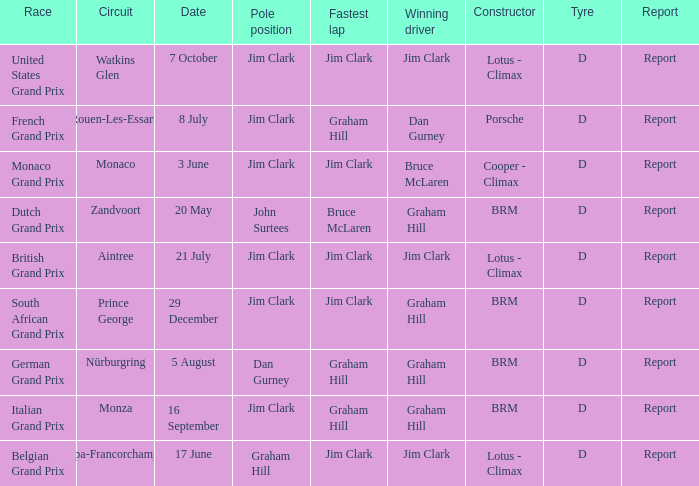Would you mind parsing the complete table? {'header': ['Race', 'Circuit', 'Date', 'Pole position', 'Fastest lap', 'Winning driver', 'Constructor', 'Tyre', 'Report'], 'rows': [['United States Grand Prix', 'Watkins Glen', '7 October', 'Jim Clark', 'Jim Clark', 'Jim Clark', 'Lotus - Climax', 'D', 'Report'], ['French Grand Prix', 'Rouen-Les-Essarts', '8 July', 'Jim Clark', 'Graham Hill', 'Dan Gurney', 'Porsche', 'D', 'Report'], ['Monaco Grand Prix', 'Monaco', '3 June', 'Jim Clark', 'Jim Clark', 'Bruce McLaren', 'Cooper - Climax', 'D', 'Report'], ['Dutch Grand Prix', 'Zandvoort', '20 May', 'John Surtees', 'Bruce McLaren', 'Graham Hill', 'BRM', 'D', 'Report'], ['British Grand Prix', 'Aintree', '21 July', 'Jim Clark', 'Jim Clark', 'Jim Clark', 'Lotus - Climax', 'D', 'Report'], ['South African Grand Prix', 'Prince George', '29 December', 'Jim Clark', 'Jim Clark', 'Graham Hill', 'BRM', 'D', 'Report'], ['German Grand Prix', 'Nürburgring', '5 August', 'Dan Gurney', 'Graham Hill', 'Graham Hill', 'BRM', 'D', 'Report'], ['Italian Grand Prix', 'Monza', '16 September', 'Jim Clark', 'Graham Hill', 'Graham Hill', 'BRM', 'D', 'Report'], ['Belgian Grand Prix', 'Spa-Francorchamps', '17 June', 'Graham Hill', 'Jim Clark', 'Jim Clark', 'Lotus - Climax', 'D', 'Report']]} What is the tyre on the race where Bruce Mclaren had the fastest lap? D. 